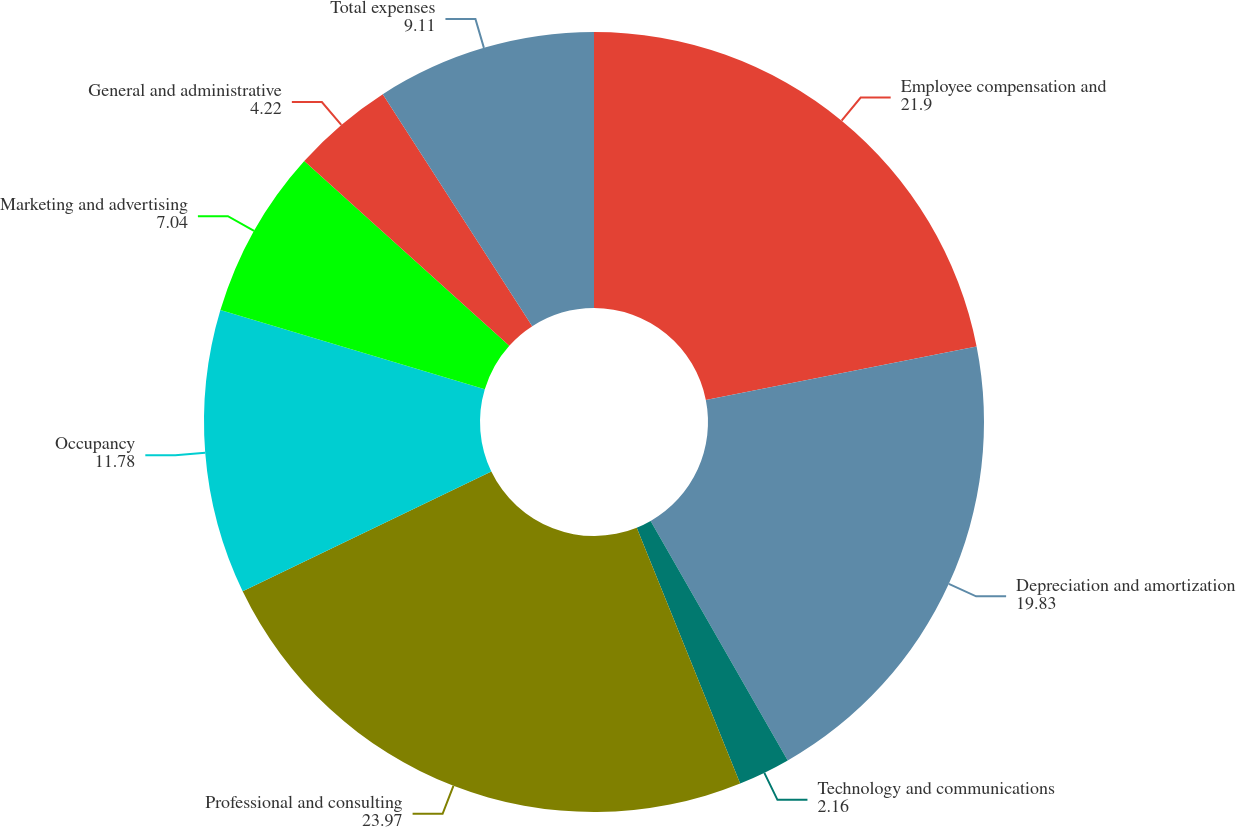Convert chart to OTSL. <chart><loc_0><loc_0><loc_500><loc_500><pie_chart><fcel>Employee compensation and<fcel>Depreciation and amortization<fcel>Technology and communications<fcel>Professional and consulting<fcel>Occupancy<fcel>Marketing and advertising<fcel>General and administrative<fcel>Total expenses<nl><fcel>21.9%<fcel>19.83%<fcel>2.16%<fcel>23.97%<fcel>11.78%<fcel>7.04%<fcel>4.22%<fcel>9.11%<nl></chart> 